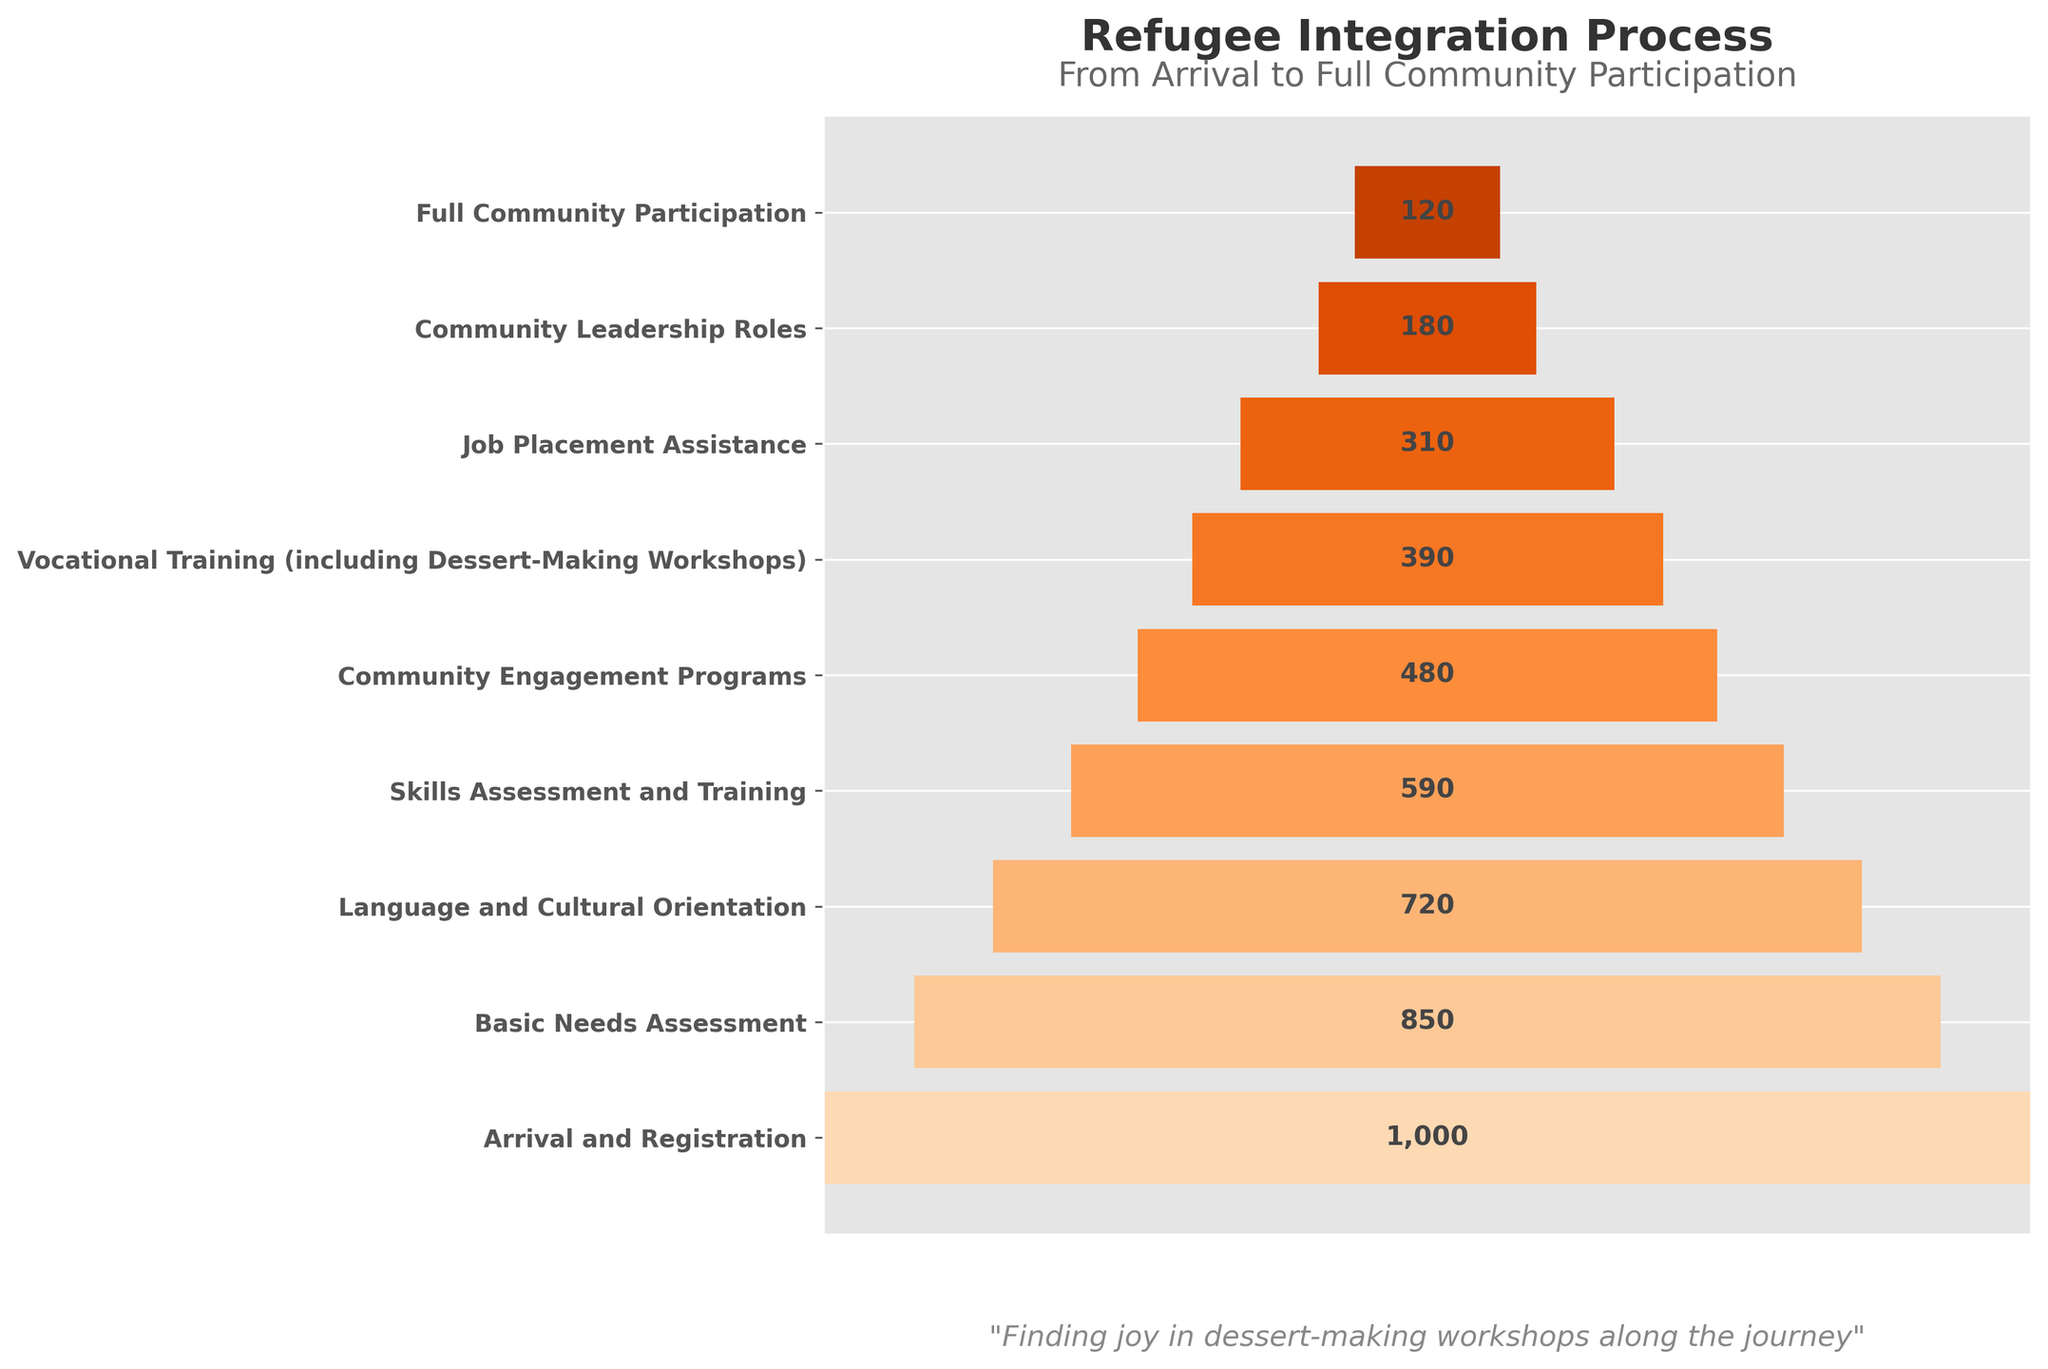What is the title of the funnel chart? The information about the title is located at the top center of the chart, which reads "Refugee Integration Process".
Answer: Refugee Integration Process How many stages are involved in the refugee integration process according to the chart? Count the number of horizontal bars representing each stage from top to bottom. There are 9 stages.
Answer: 9 What is the number of participants in the "Job Placement Assistance" stage? Find the horizontal bar labeled "Job Placement Assistance" and read the number placed at the center of it, which shows 310 participants.
Answer: 310 Which stage has the highest number of participants? Observe all the bars and find the bar with the maximum extension to the edges. The “Arrival and Registration” stage, with 1000 participants, is the widest bar.
Answer: Arrival and Registration By how many participants does the "Language and Cultural Orientation" stage decrease compared to the "Basic Needs Assessment" stage? Subtract the number of participants in the "Language and Cultural Orientation" stage (720) from those in the "Basic Needs Assessment" stage (850). 850 - 720 = 130.
Answer: 130 Which stage has fewer participants: "Community Leadership Roles" or "Vocational Training (including Dessert-Making Workshops)"? Compare the number of participants in "Community Leadership Roles" (180) and "Vocational Training (including Dessert-Making Workshops)" (390). Since 180 is less than 390, "Community Leadership Roles" has fewer participants.
Answer: Community Leadership Roles What is the difference in participant numbers between the "Skills Assessment and Training" stage and the "Community Engagement Programs" stage? Subtract the number of participants in "Community Engagement Programs" (480) from the number in "Skills Assessment and Training" (590). 590 - 480 = 110.
Answer: 110 Which stages have less than 500 participants? Identify and list all stages with participant numbers below 500. These stages are "Community Engagement Programs" (480), "Vocational Training (including Dessert-Making Workshops)" (390), "Job Placement Assistance" (310), "Community Leadership Roles" (180), and "Full Community Participation" (120).
Answer: Community Engagement Programs, Vocational Training (including Dessert-Making Workshops), Job Placement Assistance, Community Leadership Roles, Full Community Participation By how many participants does the "Full Community Participation" stage decrease compared to the "Arrival and Registration" stage? Subtract the number of participants in the "Full Community Participation" stage (120) from those in the "Arrival and Registration" stage (1000). 1000 - 120 = 880.
Answer: 880 What is the median number of participants in all stages of the funnel chart? List the number of participants for all stages in ascending order (120, 180, 310, 390, 480, 590, 720, 850, 1000) and find the middle value, which is the fifth number, 480.
Answer: 480 